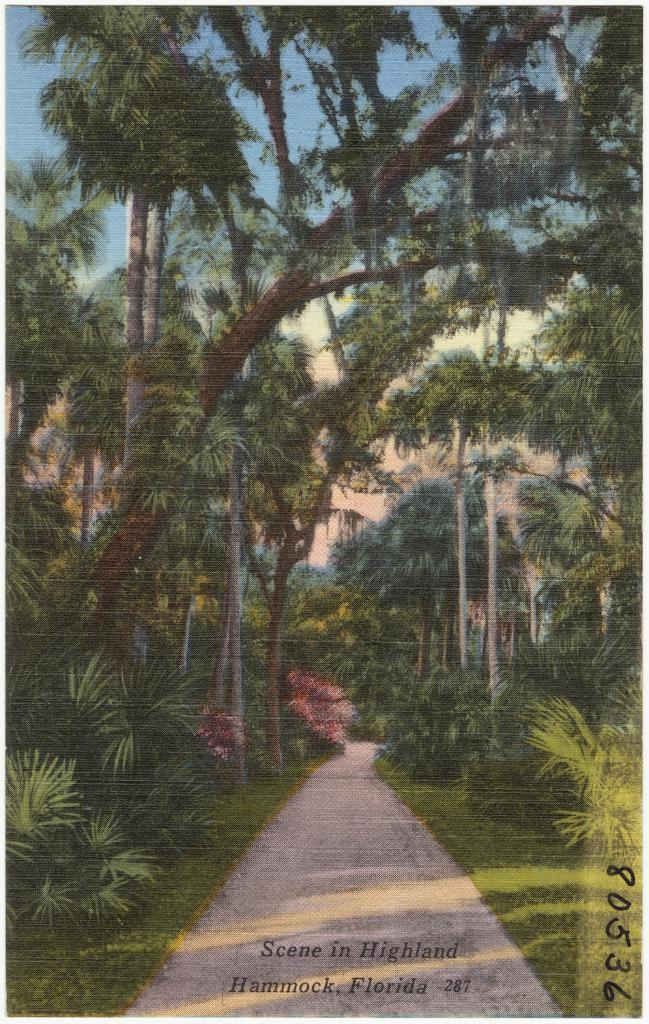What type of vegetation can be seen in the image? There is a group of trees and grass visible in the image. What is visible in the background of the image? The sky is visible in the image. What is located at the bottom of the image? There is a road at the bottom of the image. Are there any words or letters in the image? Yes, there is text in the image. What songs can be heard playing in the background of the image? There is no audio or music present in the image, so it is not possible to determine what songs might be heard. 